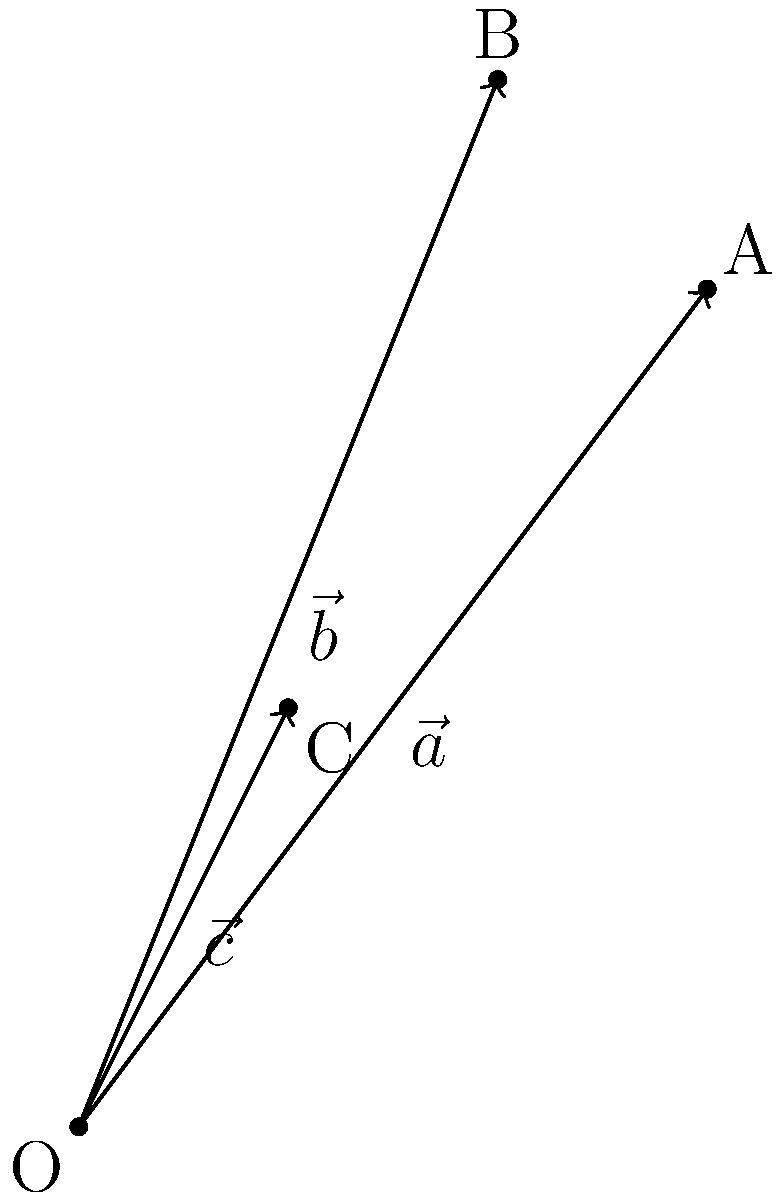You're developing a new eco-friendly vegan paint mixture using three different plant-based pigments. The composition of the mixture is represented by the vector $\vec{v} = 2\vec{a} + 3\vec{b} - \vec{c}$, where $\vec{a}$, $\vec{b}$, and $\vec{c}$ represent the individual pigment vectors as shown in the diagram. Calculate the magnitude of the resulting mixture vector $\vec{v}$. To find the magnitude of vector $\vec{v}$, we need to follow these steps:

1) First, we need to determine the components of vectors $\vec{a}$, $\vec{b}$, and $\vec{c}$:
   $\vec{a} = (3, 4)$
   $\vec{b} = (2, 5)$
   $\vec{c} = (1, 2)$

2) Now, let's calculate $\vec{v}$ using the given equation:
   $\vec{v} = 2\vec{a} + 3\vec{b} - \vec{c}$
   $\vec{v} = 2(3, 4) + 3(2, 5) - (1, 2)$
   $\vec{v} = (6, 8) + (6, 15) - (1, 2)$
   $\vec{v} = (11, 21)$

3) To find the magnitude of $\vec{v}$, we use the Pythagorean theorem:
   $|\vec{v}| = \sqrt{x^2 + y^2}$, where $x$ and $y$ are the components of $\vec{v}$

4) Substituting the values:
   $|\vec{v}| = \sqrt{11^2 + 21^2}$
   $|\vec{v}| = \sqrt{121 + 441}$
   $|\vec{v}| = \sqrt{562}$

5) Simplifying:
   $|\vec{v}| = \sqrt{562} \approx 23.71$

Therefore, the magnitude of the mixture vector $\vec{v}$ is approximately 23.71 units.
Answer: $\sqrt{562} \approx 23.71$ 